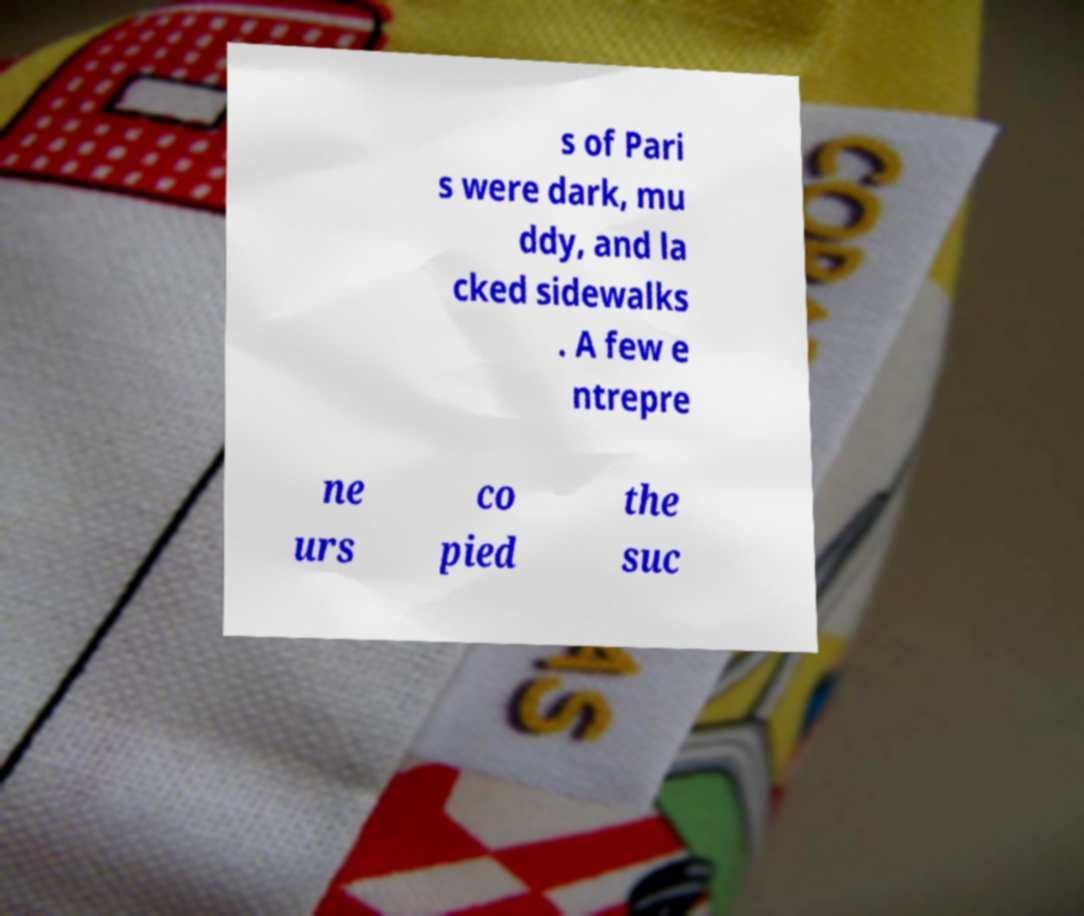Could you assist in decoding the text presented in this image and type it out clearly? s of Pari s were dark, mu ddy, and la cked sidewalks . A few e ntrepre ne urs co pied the suc 